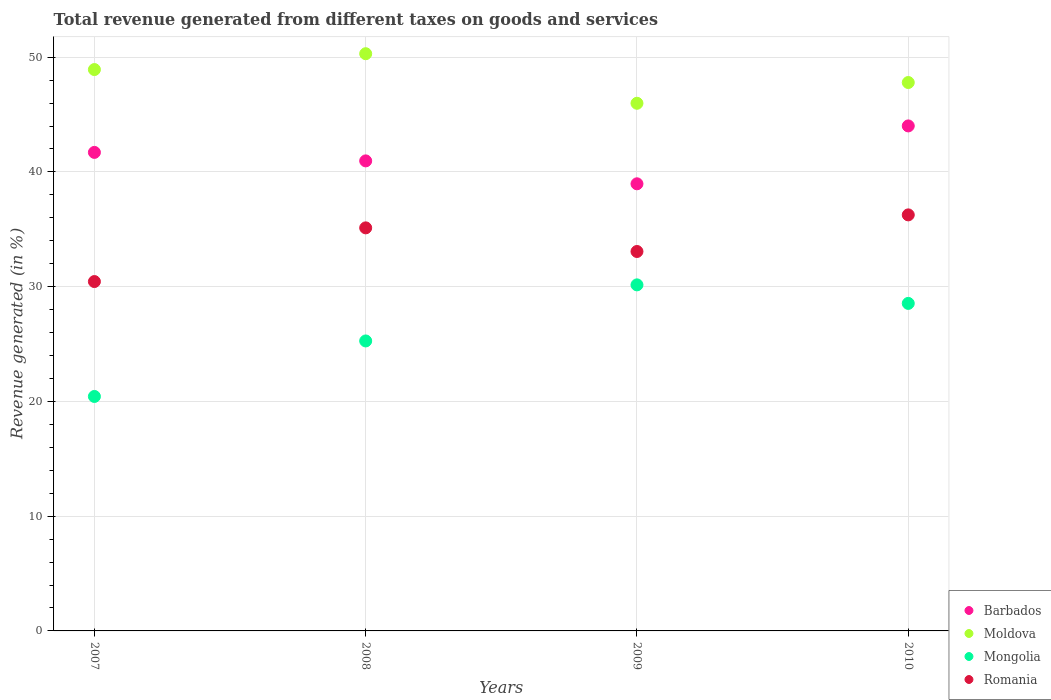How many different coloured dotlines are there?
Offer a terse response. 4. What is the total revenue generated in Mongolia in 2010?
Your answer should be compact. 28.54. Across all years, what is the maximum total revenue generated in Romania?
Give a very brief answer. 36.26. Across all years, what is the minimum total revenue generated in Mongolia?
Ensure brevity in your answer.  20.43. In which year was the total revenue generated in Barbados maximum?
Offer a very short reply. 2010. What is the total total revenue generated in Mongolia in the graph?
Your answer should be compact. 104.4. What is the difference between the total revenue generated in Mongolia in 2008 and that in 2009?
Provide a succinct answer. -4.89. What is the difference between the total revenue generated in Barbados in 2010 and the total revenue generated in Mongolia in 2008?
Provide a succinct answer. 18.74. What is the average total revenue generated in Moldova per year?
Give a very brief answer. 48.25. In the year 2009, what is the difference between the total revenue generated in Barbados and total revenue generated in Mongolia?
Ensure brevity in your answer.  8.81. What is the ratio of the total revenue generated in Barbados in 2007 to that in 2010?
Ensure brevity in your answer.  0.95. Is the difference between the total revenue generated in Barbados in 2007 and 2009 greater than the difference between the total revenue generated in Mongolia in 2007 and 2009?
Your answer should be compact. Yes. What is the difference between the highest and the second highest total revenue generated in Moldova?
Offer a very short reply. 1.38. What is the difference between the highest and the lowest total revenue generated in Romania?
Your response must be concise. 5.81. Is the sum of the total revenue generated in Mongolia in 2007 and 2008 greater than the maximum total revenue generated in Barbados across all years?
Your answer should be compact. Yes. Is it the case that in every year, the sum of the total revenue generated in Moldova and total revenue generated in Romania  is greater than the sum of total revenue generated in Mongolia and total revenue generated in Barbados?
Give a very brief answer. Yes. Is it the case that in every year, the sum of the total revenue generated in Mongolia and total revenue generated in Romania  is greater than the total revenue generated in Barbados?
Offer a very short reply. Yes. How many dotlines are there?
Offer a terse response. 4. Are the values on the major ticks of Y-axis written in scientific E-notation?
Keep it short and to the point. No. Does the graph contain grids?
Keep it short and to the point. Yes. How many legend labels are there?
Provide a short and direct response. 4. What is the title of the graph?
Your response must be concise. Total revenue generated from different taxes on goods and services. What is the label or title of the Y-axis?
Keep it short and to the point. Revenue generated (in %). What is the Revenue generated (in %) of Barbados in 2007?
Give a very brief answer. 41.7. What is the Revenue generated (in %) in Moldova in 2007?
Make the answer very short. 48.92. What is the Revenue generated (in %) in Mongolia in 2007?
Your answer should be compact. 20.43. What is the Revenue generated (in %) of Romania in 2007?
Your answer should be compact. 30.45. What is the Revenue generated (in %) in Barbados in 2008?
Offer a very short reply. 40.96. What is the Revenue generated (in %) in Moldova in 2008?
Your response must be concise. 50.3. What is the Revenue generated (in %) of Mongolia in 2008?
Make the answer very short. 25.27. What is the Revenue generated (in %) of Romania in 2008?
Offer a terse response. 35.13. What is the Revenue generated (in %) of Barbados in 2009?
Give a very brief answer. 38.97. What is the Revenue generated (in %) in Moldova in 2009?
Keep it short and to the point. 45.98. What is the Revenue generated (in %) in Mongolia in 2009?
Your answer should be compact. 30.16. What is the Revenue generated (in %) of Romania in 2009?
Your answer should be compact. 33.07. What is the Revenue generated (in %) in Barbados in 2010?
Keep it short and to the point. 44.01. What is the Revenue generated (in %) of Moldova in 2010?
Provide a succinct answer. 47.79. What is the Revenue generated (in %) of Mongolia in 2010?
Your response must be concise. 28.54. What is the Revenue generated (in %) in Romania in 2010?
Ensure brevity in your answer.  36.26. Across all years, what is the maximum Revenue generated (in %) of Barbados?
Offer a terse response. 44.01. Across all years, what is the maximum Revenue generated (in %) of Moldova?
Ensure brevity in your answer.  50.3. Across all years, what is the maximum Revenue generated (in %) of Mongolia?
Make the answer very short. 30.16. Across all years, what is the maximum Revenue generated (in %) of Romania?
Your answer should be very brief. 36.26. Across all years, what is the minimum Revenue generated (in %) in Barbados?
Your response must be concise. 38.97. Across all years, what is the minimum Revenue generated (in %) of Moldova?
Make the answer very short. 45.98. Across all years, what is the minimum Revenue generated (in %) of Mongolia?
Your response must be concise. 20.43. Across all years, what is the minimum Revenue generated (in %) in Romania?
Your response must be concise. 30.45. What is the total Revenue generated (in %) in Barbados in the graph?
Provide a short and direct response. 165.64. What is the total Revenue generated (in %) in Moldova in the graph?
Your answer should be very brief. 193. What is the total Revenue generated (in %) in Mongolia in the graph?
Offer a very short reply. 104.4. What is the total Revenue generated (in %) in Romania in the graph?
Provide a succinct answer. 134.9. What is the difference between the Revenue generated (in %) of Barbados in 2007 and that in 2008?
Give a very brief answer. 0.74. What is the difference between the Revenue generated (in %) in Moldova in 2007 and that in 2008?
Keep it short and to the point. -1.38. What is the difference between the Revenue generated (in %) in Mongolia in 2007 and that in 2008?
Make the answer very short. -4.84. What is the difference between the Revenue generated (in %) of Romania in 2007 and that in 2008?
Your answer should be compact. -4.68. What is the difference between the Revenue generated (in %) in Barbados in 2007 and that in 2009?
Your answer should be compact. 2.74. What is the difference between the Revenue generated (in %) of Moldova in 2007 and that in 2009?
Keep it short and to the point. 2.94. What is the difference between the Revenue generated (in %) of Mongolia in 2007 and that in 2009?
Your answer should be compact. -9.73. What is the difference between the Revenue generated (in %) of Romania in 2007 and that in 2009?
Make the answer very short. -2.62. What is the difference between the Revenue generated (in %) in Barbados in 2007 and that in 2010?
Provide a succinct answer. -2.31. What is the difference between the Revenue generated (in %) in Moldova in 2007 and that in 2010?
Make the answer very short. 1.13. What is the difference between the Revenue generated (in %) in Mongolia in 2007 and that in 2010?
Provide a short and direct response. -8.11. What is the difference between the Revenue generated (in %) in Romania in 2007 and that in 2010?
Keep it short and to the point. -5.81. What is the difference between the Revenue generated (in %) in Barbados in 2008 and that in 2009?
Give a very brief answer. 2. What is the difference between the Revenue generated (in %) in Moldova in 2008 and that in 2009?
Ensure brevity in your answer.  4.32. What is the difference between the Revenue generated (in %) in Mongolia in 2008 and that in 2009?
Give a very brief answer. -4.89. What is the difference between the Revenue generated (in %) in Romania in 2008 and that in 2009?
Your answer should be very brief. 2.06. What is the difference between the Revenue generated (in %) in Barbados in 2008 and that in 2010?
Offer a very short reply. -3.05. What is the difference between the Revenue generated (in %) in Moldova in 2008 and that in 2010?
Offer a very short reply. 2.51. What is the difference between the Revenue generated (in %) of Mongolia in 2008 and that in 2010?
Provide a short and direct response. -3.27. What is the difference between the Revenue generated (in %) in Romania in 2008 and that in 2010?
Your answer should be compact. -1.13. What is the difference between the Revenue generated (in %) in Barbados in 2009 and that in 2010?
Give a very brief answer. -5.04. What is the difference between the Revenue generated (in %) of Moldova in 2009 and that in 2010?
Your answer should be very brief. -1.81. What is the difference between the Revenue generated (in %) in Mongolia in 2009 and that in 2010?
Keep it short and to the point. 1.61. What is the difference between the Revenue generated (in %) of Romania in 2009 and that in 2010?
Your answer should be compact. -3.19. What is the difference between the Revenue generated (in %) in Barbados in 2007 and the Revenue generated (in %) in Moldova in 2008?
Your response must be concise. -8.6. What is the difference between the Revenue generated (in %) in Barbados in 2007 and the Revenue generated (in %) in Mongolia in 2008?
Give a very brief answer. 16.43. What is the difference between the Revenue generated (in %) in Barbados in 2007 and the Revenue generated (in %) in Romania in 2008?
Offer a very short reply. 6.58. What is the difference between the Revenue generated (in %) of Moldova in 2007 and the Revenue generated (in %) of Mongolia in 2008?
Your answer should be compact. 23.65. What is the difference between the Revenue generated (in %) in Moldova in 2007 and the Revenue generated (in %) in Romania in 2008?
Offer a terse response. 13.8. What is the difference between the Revenue generated (in %) in Mongolia in 2007 and the Revenue generated (in %) in Romania in 2008?
Your answer should be very brief. -14.69. What is the difference between the Revenue generated (in %) of Barbados in 2007 and the Revenue generated (in %) of Moldova in 2009?
Your answer should be very brief. -4.28. What is the difference between the Revenue generated (in %) of Barbados in 2007 and the Revenue generated (in %) of Mongolia in 2009?
Provide a succinct answer. 11.54. What is the difference between the Revenue generated (in %) in Barbados in 2007 and the Revenue generated (in %) in Romania in 2009?
Your answer should be compact. 8.64. What is the difference between the Revenue generated (in %) in Moldova in 2007 and the Revenue generated (in %) in Mongolia in 2009?
Ensure brevity in your answer.  18.76. What is the difference between the Revenue generated (in %) of Moldova in 2007 and the Revenue generated (in %) of Romania in 2009?
Offer a very short reply. 15.86. What is the difference between the Revenue generated (in %) in Mongolia in 2007 and the Revenue generated (in %) in Romania in 2009?
Ensure brevity in your answer.  -12.63. What is the difference between the Revenue generated (in %) of Barbados in 2007 and the Revenue generated (in %) of Moldova in 2010?
Your response must be concise. -6.09. What is the difference between the Revenue generated (in %) of Barbados in 2007 and the Revenue generated (in %) of Mongolia in 2010?
Ensure brevity in your answer.  13.16. What is the difference between the Revenue generated (in %) of Barbados in 2007 and the Revenue generated (in %) of Romania in 2010?
Provide a succinct answer. 5.45. What is the difference between the Revenue generated (in %) of Moldova in 2007 and the Revenue generated (in %) of Mongolia in 2010?
Provide a succinct answer. 20.38. What is the difference between the Revenue generated (in %) in Moldova in 2007 and the Revenue generated (in %) in Romania in 2010?
Ensure brevity in your answer.  12.66. What is the difference between the Revenue generated (in %) of Mongolia in 2007 and the Revenue generated (in %) of Romania in 2010?
Make the answer very short. -15.82. What is the difference between the Revenue generated (in %) of Barbados in 2008 and the Revenue generated (in %) of Moldova in 2009?
Provide a succinct answer. -5.02. What is the difference between the Revenue generated (in %) of Barbados in 2008 and the Revenue generated (in %) of Mongolia in 2009?
Make the answer very short. 10.81. What is the difference between the Revenue generated (in %) in Barbados in 2008 and the Revenue generated (in %) in Romania in 2009?
Your answer should be compact. 7.9. What is the difference between the Revenue generated (in %) of Moldova in 2008 and the Revenue generated (in %) of Mongolia in 2009?
Your response must be concise. 20.14. What is the difference between the Revenue generated (in %) of Moldova in 2008 and the Revenue generated (in %) of Romania in 2009?
Offer a terse response. 17.24. What is the difference between the Revenue generated (in %) of Mongolia in 2008 and the Revenue generated (in %) of Romania in 2009?
Give a very brief answer. -7.8. What is the difference between the Revenue generated (in %) of Barbados in 2008 and the Revenue generated (in %) of Moldova in 2010?
Give a very brief answer. -6.83. What is the difference between the Revenue generated (in %) of Barbados in 2008 and the Revenue generated (in %) of Mongolia in 2010?
Ensure brevity in your answer.  12.42. What is the difference between the Revenue generated (in %) in Barbados in 2008 and the Revenue generated (in %) in Romania in 2010?
Ensure brevity in your answer.  4.71. What is the difference between the Revenue generated (in %) of Moldova in 2008 and the Revenue generated (in %) of Mongolia in 2010?
Your response must be concise. 21.76. What is the difference between the Revenue generated (in %) of Moldova in 2008 and the Revenue generated (in %) of Romania in 2010?
Provide a short and direct response. 14.05. What is the difference between the Revenue generated (in %) in Mongolia in 2008 and the Revenue generated (in %) in Romania in 2010?
Give a very brief answer. -10.99. What is the difference between the Revenue generated (in %) in Barbados in 2009 and the Revenue generated (in %) in Moldova in 2010?
Your answer should be very brief. -8.83. What is the difference between the Revenue generated (in %) in Barbados in 2009 and the Revenue generated (in %) in Mongolia in 2010?
Offer a terse response. 10.42. What is the difference between the Revenue generated (in %) in Barbados in 2009 and the Revenue generated (in %) in Romania in 2010?
Your answer should be compact. 2.71. What is the difference between the Revenue generated (in %) of Moldova in 2009 and the Revenue generated (in %) of Mongolia in 2010?
Make the answer very short. 17.44. What is the difference between the Revenue generated (in %) of Moldova in 2009 and the Revenue generated (in %) of Romania in 2010?
Your response must be concise. 9.73. What is the difference between the Revenue generated (in %) of Mongolia in 2009 and the Revenue generated (in %) of Romania in 2010?
Keep it short and to the point. -6.1. What is the average Revenue generated (in %) of Barbados per year?
Your response must be concise. 41.41. What is the average Revenue generated (in %) of Moldova per year?
Give a very brief answer. 48.25. What is the average Revenue generated (in %) of Mongolia per year?
Give a very brief answer. 26.1. What is the average Revenue generated (in %) in Romania per year?
Your answer should be very brief. 33.72. In the year 2007, what is the difference between the Revenue generated (in %) of Barbados and Revenue generated (in %) of Moldova?
Ensure brevity in your answer.  -7.22. In the year 2007, what is the difference between the Revenue generated (in %) in Barbados and Revenue generated (in %) in Mongolia?
Give a very brief answer. 21.27. In the year 2007, what is the difference between the Revenue generated (in %) of Barbados and Revenue generated (in %) of Romania?
Keep it short and to the point. 11.26. In the year 2007, what is the difference between the Revenue generated (in %) of Moldova and Revenue generated (in %) of Mongolia?
Ensure brevity in your answer.  28.49. In the year 2007, what is the difference between the Revenue generated (in %) in Moldova and Revenue generated (in %) in Romania?
Offer a very short reply. 18.48. In the year 2007, what is the difference between the Revenue generated (in %) of Mongolia and Revenue generated (in %) of Romania?
Offer a terse response. -10.01. In the year 2008, what is the difference between the Revenue generated (in %) in Barbados and Revenue generated (in %) in Moldova?
Make the answer very short. -9.34. In the year 2008, what is the difference between the Revenue generated (in %) of Barbados and Revenue generated (in %) of Mongolia?
Keep it short and to the point. 15.69. In the year 2008, what is the difference between the Revenue generated (in %) in Barbados and Revenue generated (in %) in Romania?
Ensure brevity in your answer.  5.84. In the year 2008, what is the difference between the Revenue generated (in %) in Moldova and Revenue generated (in %) in Mongolia?
Your answer should be compact. 25.03. In the year 2008, what is the difference between the Revenue generated (in %) in Moldova and Revenue generated (in %) in Romania?
Your answer should be compact. 15.18. In the year 2008, what is the difference between the Revenue generated (in %) in Mongolia and Revenue generated (in %) in Romania?
Provide a short and direct response. -9.85. In the year 2009, what is the difference between the Revenue generated (in %) in Barbados and Revenue generated (in %) in Moldova?
Your answer should be compact. -7.02. In the year 2009, what is the difference between the Revenue generated (in %) in Barbados and Revenue generated (in %) in Mongolia?
Keep it short and to the point. 8.81. In the year 2009, what is the difference between the Revenue generated (in %) in Barbados and Revenue generated (in %) in Romania?
Make the answer very short. 5.9. In the year 2009, what is the difference between the Revenue generated (in %) of Moldova and Revenue generated (in %) of Mongolia?
Your answer should be compact. 15.83. In the year 2009, what is the difference between the Revenue generated (in %) in Moldova and Revenue generated (in %) in Romania?
Make the answer very short. 12.92. In the year 2009, what is the difference between the Revenue generated (in %) of Mongolia and Revenue generated (in %) of Romania?
Offer a terse response. -2.91. In the year 2010, what is the difference between the Revenue generated (in %) of Barbados and Revenue generated (in %) of Moldova?
Make the answer very short. -3.78. In the year 2010, what is the difference between the Revenue generated (in %) of Barbados and Revenue generated (in %) of Mongolia?
Make the answer very short. 15.47. In the year 2010, what is the difference between the Revenue generated (in %) in Barbados and Revenue generated (in %) in Romania?
Provide a succinct answer. 7.75. In the year 2010, what is the difference between the Revenue generated (in %) in Moldova and Revenue generated (in %) in Mongolia?
Your answer should be compact. 19.25. In the year 2010, what is the difference between the Revenue generated (in %) of Moldova and Revenue generated (in %) of Romania?
Give a very brief answer. 11.53. In the year 2010, what is the difference between the Revenue generated (in %) in Mongolia and Revenue generated (in %) in Romania?
Ensure brevity in your answer.  -7.71. What is the ratio of the Revenue generated (in %) in Barbados in 2007 to that in 2008?
Provide a short and direct response. 1.02. What is the ratio of the Revenue generated (in %) in Moldova in 2007 to that in 2008?
Give a very brief answer. 0.97. What is the ratio of the Revenue generated (in %) in Mongolia in 2007 to that in 2008?
Offer a terse response. 0.81. What is the ratio of the Revenue generated (in %) of Romania in 2007 to that in 2008?
Provide a succinct answer. 0.87. What is the ratio of the Revenue generated (in %) in Barbados in 2007 to that in 2009?
Keep it short and to the point. 1.07. What is the ratio of the Revenue generated (in %) in Moldova in 2007 to that in 2009?
Your answer should be compact. 1.06. What is the ratio of the Revenue generated (in %) of Mongolia in 2007 to that in 2009?
Make the answer very short. 0.68. What is the ratio of the Revenue generated (in %) in Romania in 2007 to that in 2009?
Make the answer very short. 0.92. What is the ratio of the Revenue generated (in %) of Barbados in 2007 to that in 2010?
Give a very brief answer. 0.95. What is the ratio of the Revenue generated (in %) in Moldova in 2007 to that in 2010?
Your answer should be compact. 1.02. What is the ratio of the Revenue generated (in %) in Mongolia in 2007 to that in 2010?
Your response must be concise. 0.72. What is the ratio of the Revenue generated (in %) in Romania in 2007 to that in 2010?
Your answer should be compact. 0.84. What is the ratio of the Revenue generated (in %) in Barbados in 2008 to that in 2009?
Your answer should be very brief. 1.05. What is the ratio of the Revenue generated (in %) in Moldova in 2008 to that in 2009?
Make the answer very short. 1.09. What is the ratio of the Revenue generated (in %) in Mongolia in 2008 to that in 2009?
Your response must be concise. 0.84. What is the ratio of the Revenue generated (in %) in Romania in 2008 to that in 2009?
Keep it short and to the point. 1.06. What is the ratio of the Revenue generated (in %) in Barbados in 2008 to that in 2010?
Your answer should be very brief. 0.93. What is the ratio of the Revenue generated (in %) in Moldova in 2008 to that in 2010?
Your answer should be very brief. 1.05. What is the ratio of the Revenue generated (in %) in Mongolia in 2008 to that in 2010?
Ensure brevity in your answer.  0.89. What is the ratio of the Revenue generated (in %) in Romania in 2008 to that in 2010?
Give a very brief answer. 0.97. What is the ratio of the Revenue generated (in %) in Barbados in 2009 to that in 2010?
Make the answer very short. 0.89. What is the ratio of the Revenue generated (in %) in Moldova in 2009 to that in 2010?
Offer a very short reply. 0.96. What is the ratio of the Revenue generated (in %) in Mongolia in 2009 to that in 2010?
Your answer should be compact. 1.06. What is the ratio of the Revenue generated (in %) of Romania in 2009 to that in 2010?
Provide a succinct answer. 0.91. What is the difference between the highest and the second highest Revenue generated (in %) in Barbados?
Make the answer very short. 2.31. What is the difference between the highest and the second highest Revenue generated (in %) in Moldova?
Provide a short and direct response. 1.38. What is the difference between the highest and the second highest Revenue generated (in %) of Mongolia?
Provide a succinct answer. 1.61. What is the difference between the highest and the second highest Revenue generated (in %) of Romania?
Your answer should be compact. 1.13. What is the difference between the highest and the lowest Revenue generated (in %) of Barbados?
Provide a short and direct response. 5.04. What is the difference between the highest and the lowest Revenue generated (in %) of Moldova?
Provide a succinct answer. 4.32. What is the difference between the highest and the lowest Revenue generated (in %) of Mongolia?
Offer a terse response. 9.73. What is the difference between the highest and the lowest Revenue generated (in %) in Romania?
Provide a succinct answer. 5.81. 